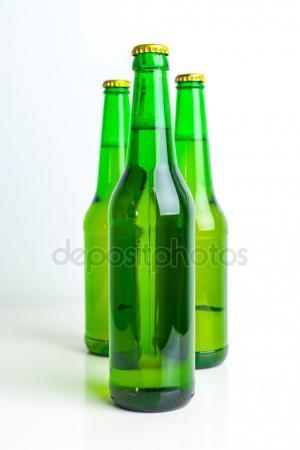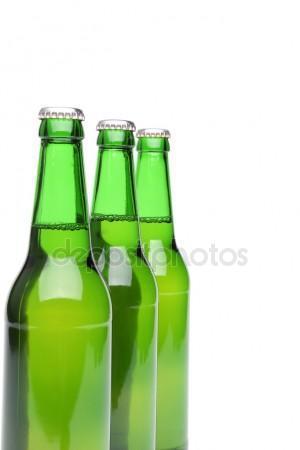The first image is the image on the left, the second image is the image on the right. Examine the images to the left and right. Is the description "One image contains a diagonal row of three overlapping green bottles with liquid inside and caps on." accurate? Answer yes or no. Yes. The first image is the image on the left, the second image is the image on the right. Given the left and right images, does the statement "All the bottles are full." hold true? Answer yes or no. Yes. 